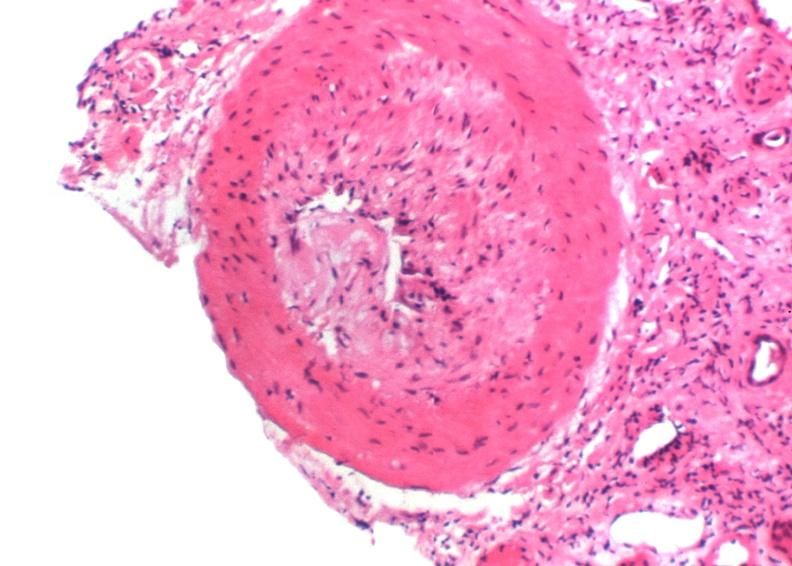does jejunum show kidney transplant rejection?
Answer the question using a single word or phrase. No 